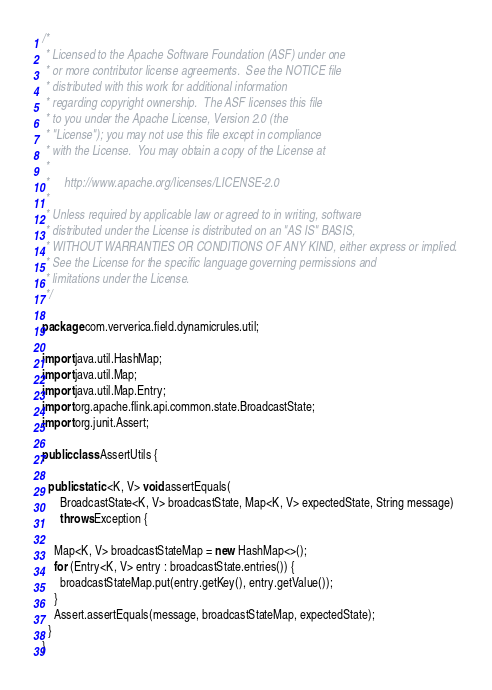<code> <loc_0><loc_0><loc_500><loc_500><_Java_>/*
 * Licensed to the Apache Software Foundation (ASF) under one
 * or more contributor license agreements.  See the NOTICE file
 * distributed with this work for additional information
 * regarding copyright ownership.  The ASF licenses this file
 * to you under the Apache License, Version 2.0 (the
 * "License"); you may not use this file except in compliance
 * with the License.  You may obtain a copy of the License at
 *
 *     http://www.apache.org/licenses/LICENSE-2.0
 *
 * Unless required by applicable law or agreed to in writing, software
 * distributed under the License is distributed on an "AS IS" BASIS,
 * WITHOUT WARRANTIES OR CONDITIONS OF ANY KIND, either express or implied.
 * See the License for the specific language governing permissions and
 * limitations under the License.
 */

package com.ververica.field.dynamicrules.util;

import java.util.HashMap;
import java.util.Map;
import java.util.Map.Entry;
import org.apache.flink.api.common.state.BroadcastState;
import org.junit.Assert;

public class AssertUtils {

  public static <K, V> void assertEquals(
      BroadcastState<K, V> broadcastState, Map<K, V> expectedState, String message)
      throws Exception {

    Map<K, V> broadcastStateMap = new HashMap<>();
    for (Entry<K, V> entry : broadcastState.entries()) {
      broadcastStateMap.put(entry.getKey(), entry.getValue());
    }
    Assert.assertEquals(message, broadcastStateMap, expectedState);
  }
}
</code> 